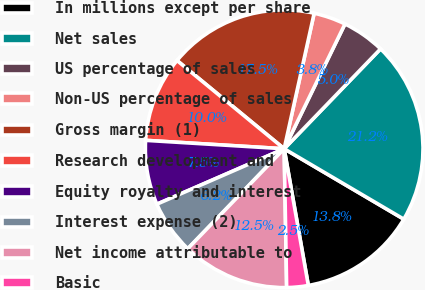Convert chart. <chart><loc_0><loc_0><loc_500><loc_500><pie_chart><fcel>In millions except per share<fcel>Net sales<fcel>US percentage of sales<fcel>Non-US percentage of sales<fcel>Gross margin (1)<fcel>Research development and<fcel>Equity royalty and interest<fcel>Interest expense (2)<fcel>Net income attributable to<fcel>Basic<nl><fcel>13.75%<fcel>21.25%<fcel>5.0%<fcel>3.75%<fcel>17.5%<fcel>10.0%<fcel>7.5%<fcel>6.25%<fcel>12.5%<fcel>2.5%<nl></chart> 